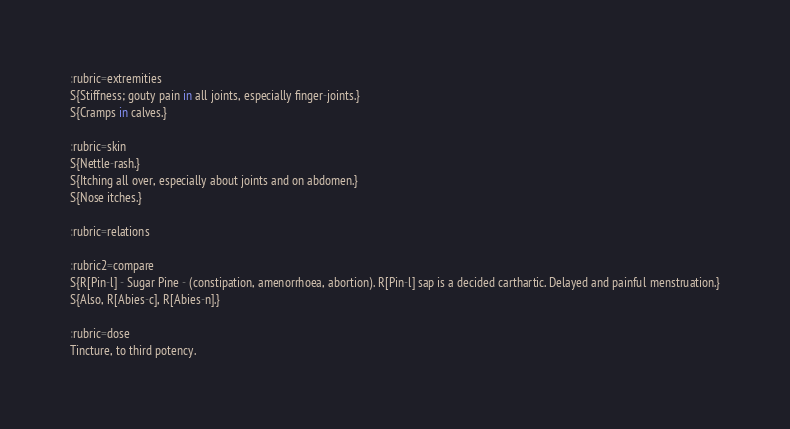<code> <loc_0><loc_0><loc_500><loc_500><_ObjectiveC_>
:rubric=extremities
S{Stiffness; gouty pain in all joints, especially finger-joints.}
S{Cramps in calves.}

:rubric=skin
S{Nettle-rash.}
S{Itching all over, especially about joints and on abdomen.}
S{Nose itches.}

:rubric=relations

:rubric2=compare
S{R[Pin-l] - Sugar Pine - (constipation, amenorrhoea, abortion). R[Pin-l] sap is a decided carthartic. Delayed and painful menstruation.}
S{Also, R[Abies-c], R[Abies-n].}

:rubric=dose
Tincture, to third potency.</code> 